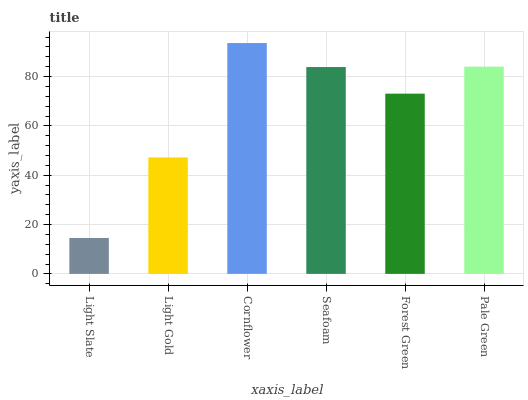Is Light Slate the minimum?
Answer yes or no. Yes. Is Cornflower the maximum?
Answer yes or no. Yes. Is Light Gold the minimum?
Answer yes or no. No. Is Light Gold the maximum?
Answer yes or no. No. Is Light Gold greater than Light Slate?
Answer yes or no. Yes. Is Light Slate less than Light Gold?
Answer yes or no. Yes. Is Light Slate greater than Light Gold?
Answer yes or no. No. Is Light Gold less than Light Slate?
Answer yes or no. No. Is Seafoam the high median?
Answer yes or no. Yes. Is Forest Green the low median?
Answer yes or no. Yes. Is Forest Green the high median?
Answer yes or no. No. Is Pale Green the low median?
Answer yes or no. No. 